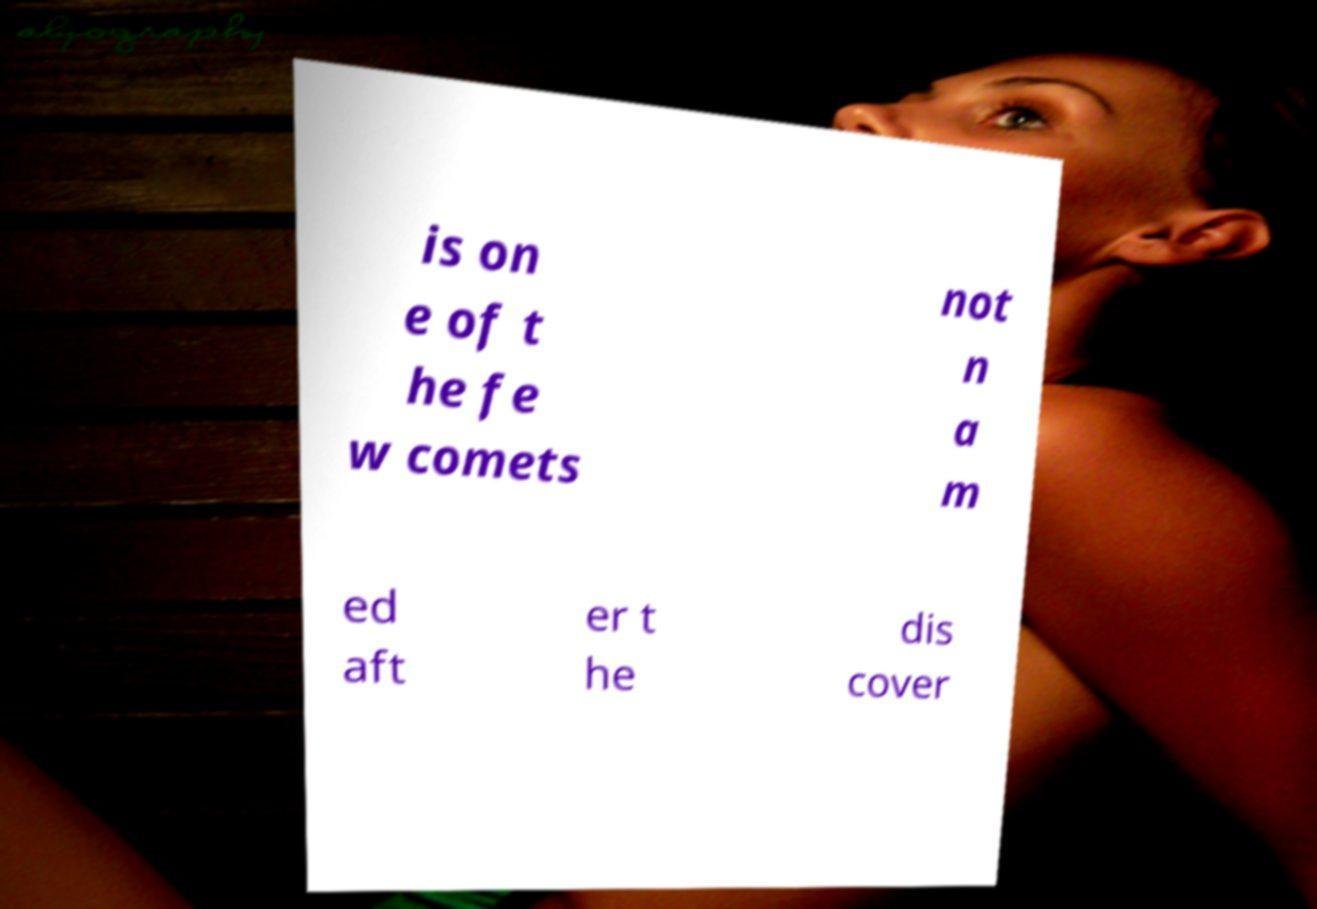Can you read and provide the text displayed in the image?This photo seems to have some interesting text. Can you extract and type it out for me? is on e of t he fe w comets not n a m ed aft er t he dis cover 